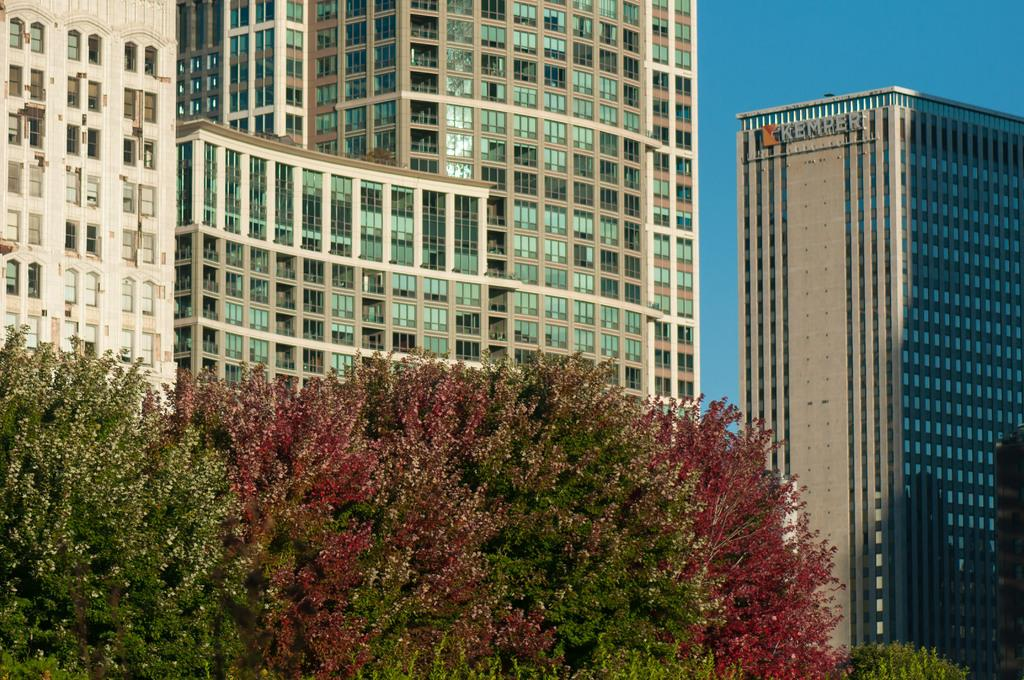What type of buildings are shown in the image? There are skyscrapers in the image. What feature do the skyscrapers have? The skyscrapers have windows. What is located at the bottom of the image? There are plants at the bottom of the image. What colors are the leaves of the plants? The leaves of the plants are in green and red colors. What is visible at the top of the image? The sky is visible at the top of the image. How quiet is the knot in the image? There is no knot present in the image, so it cannot be described as quiet or any other characteristic. 